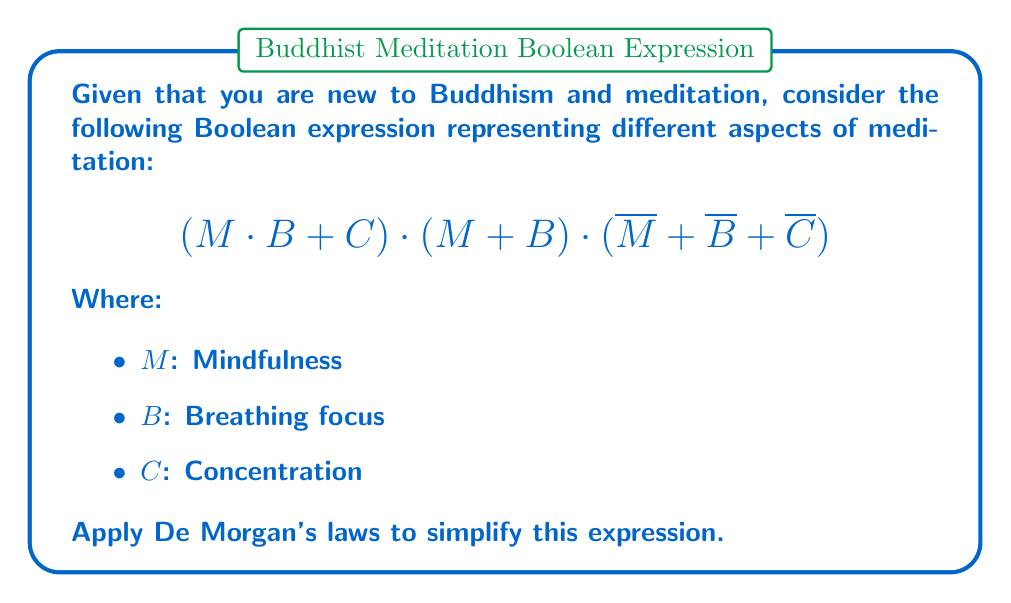Could you help me with this problem? Let's simplify the expression step by step using De Morgan's laws:

1) First, let's apply De Morgan's law to the last term $(\overline{M} + \overline{B} + \overline{C})$:
   $(\overline{M} + \overline{B} + \overline{C}) = \overline{(M \cdot B \cdot C)}$

2) Now our expression looks like:
   $$(M \cdot B + C) \cdot (M + B) \cdot \overline{(M \cdot B \cdot C)}$$

3) Let's apply the distributive law to $(M \cdot B + C)$:
   $(M \cdot B + C) = (M + C) \cdot (B + C)$

4) Our expression is now:
   $$(M + C) \cdot (B + C) \cdot (M + B) \cdot \overline{(M \cdot B \cdot C)}$$

5) We can rearrange the terms:
   $$(M + C) \cdot (M + B) \cdot (B + C) \cdot \overline{(M \cdot B \cdot C)}$$

6) Apply the absorption law to $(M + C) \cdot (M + B)$:
   $(M + C) \cdot (M + B) = M + (C \cdot B)$

7) Our final simplified expression is:
   $$(M + (C \cdot B)) \cdot (B + C) \cdot \overline{(M \cdot B \cdot C)}$$

This simplified expression represents the combination of meditation aspects that are present in the practice.
Answer: $$(M + (C \cdot B)) \cdot (B + C) \cdot \overline{(M \cdot B \cdot C)}$$ 